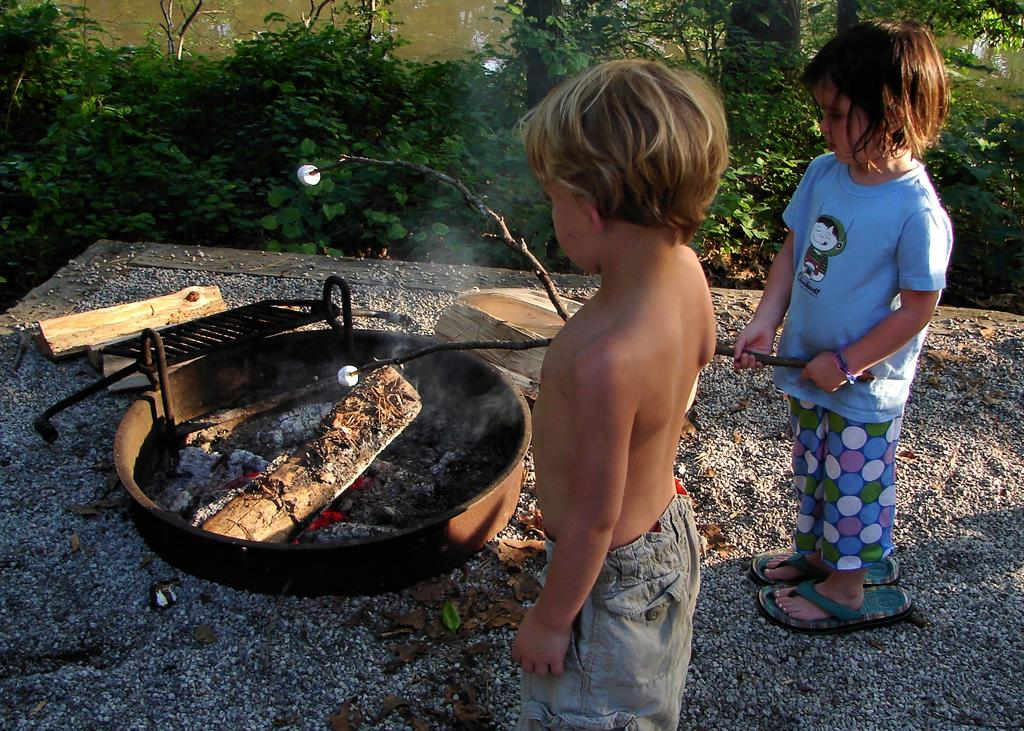Who are the people in the picture? There is a boy and a girl in the picture. What are the boy and girl doing in the picture? The boy and girl are standing near a dish. What can be seen in the foreground of the picture? There is wood and charcoal with a lot of fire in the picture. What is visible in the background of the picture? There are plants visible in the background of the picture. What hobbies do the boy and girl share in the picture? The provided facts do not mention any hobbies of the boy and girl, so we cannot determine their shared hobbies from the image. 